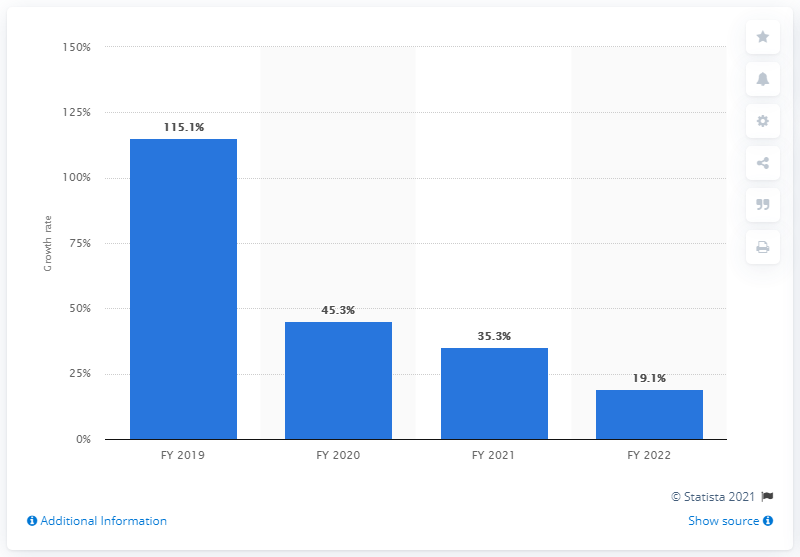Highlight a few significant elements in this photo. Reliance Jio's net revenue growth rate at the end of fiscal year 2020 was 115.1%. Reliance Jio projected a revenue growth rate of 19.1% by the end of fiscal year 2022. 